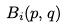<formula> <loc_0><loc_0><loc_500><loc_500>B _ { i } ( p , q )</formula> 